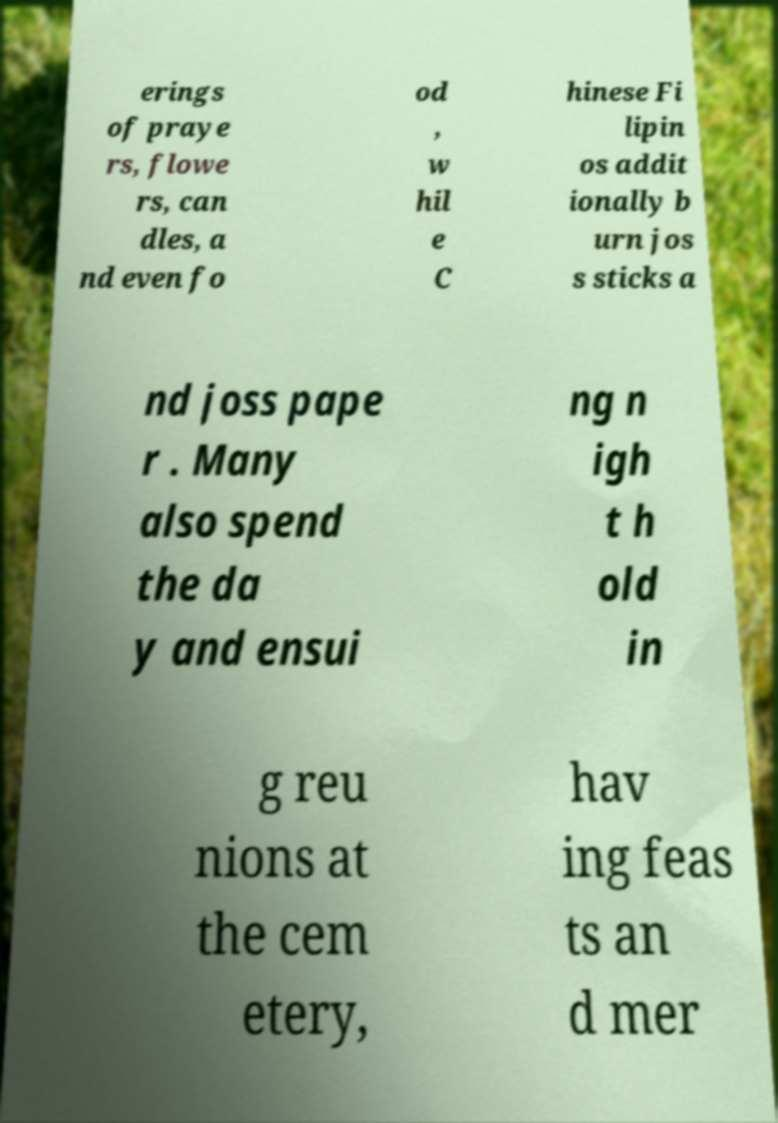Could you extract and type out the text from this image? erings of praye rs, flowe rs, can dles, a nd even fo od , w hil e C hinese Fi lipin os addit ionally b urn jos s sticks a nd joss pape r . Many also spend the da y and ensui ng n igh t h old in g reu nions at the cem etery, hav ing feas ts an d mer 